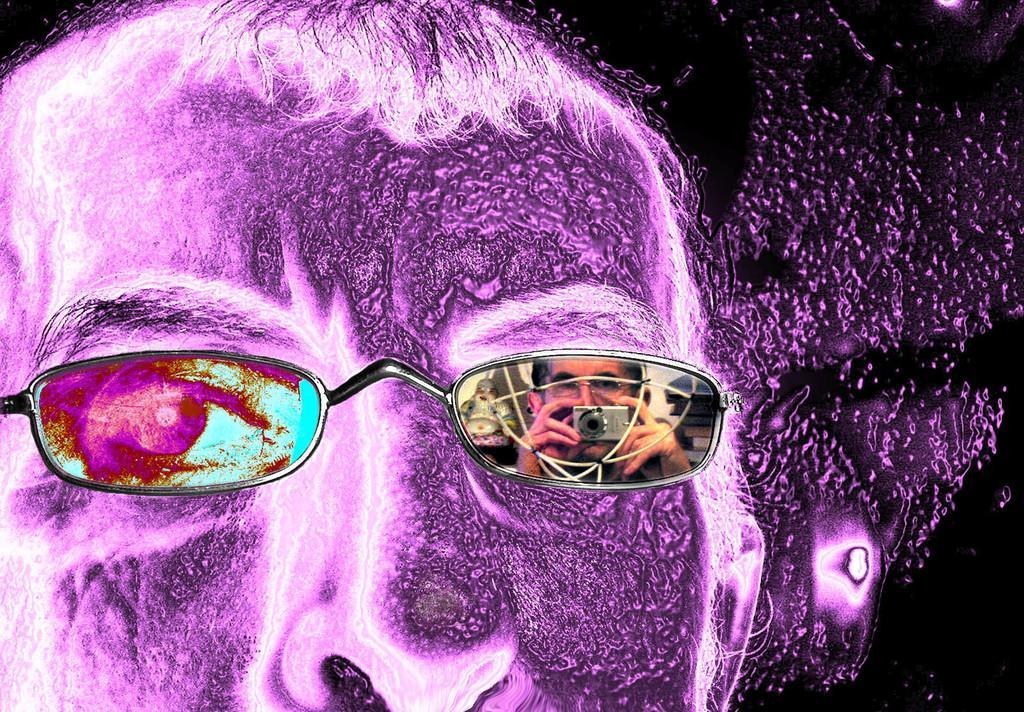Describe this image in one or two sentences. This is a animated picture and here we can see spectacles. On this glass we can see the reflection of a person holding a camera. 